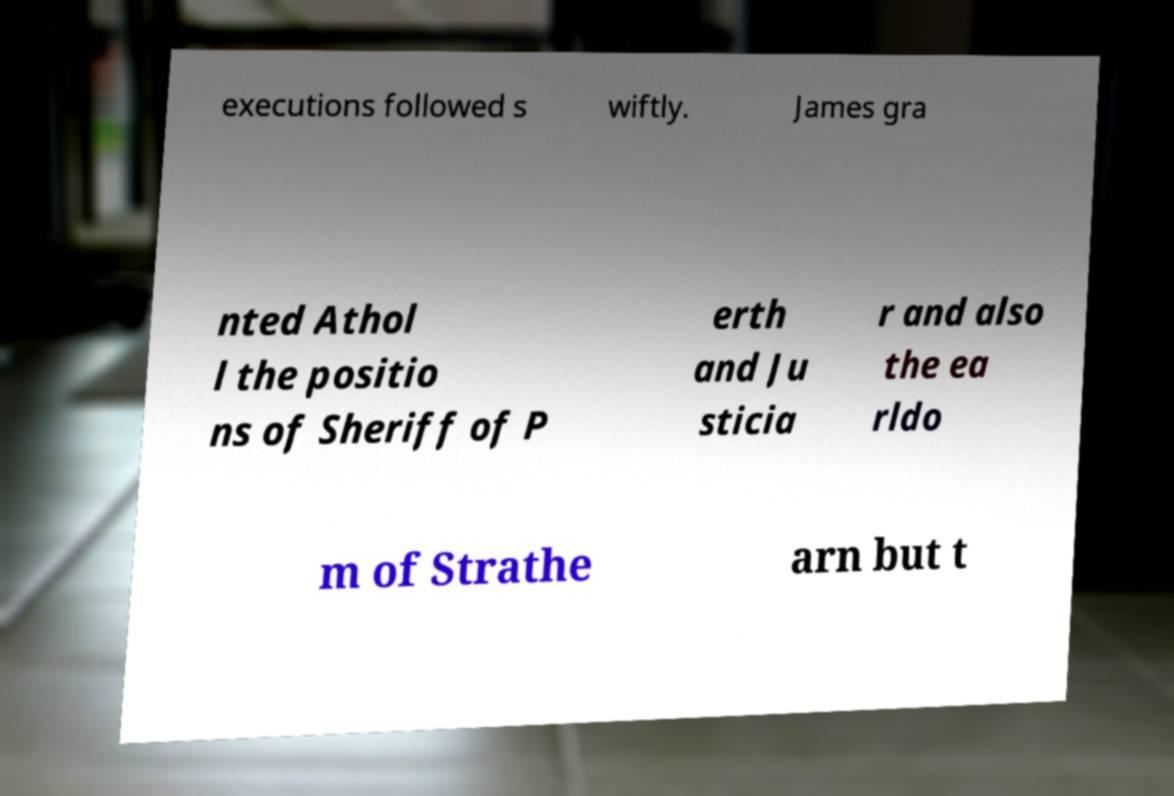Please identify and transcribe the text found in this image. executions followed s wiftly. James gra nted Athol l the positio ns of Sheriff of P erth and Ju sticia r and also the ea rldo m of Strathe arn but t 